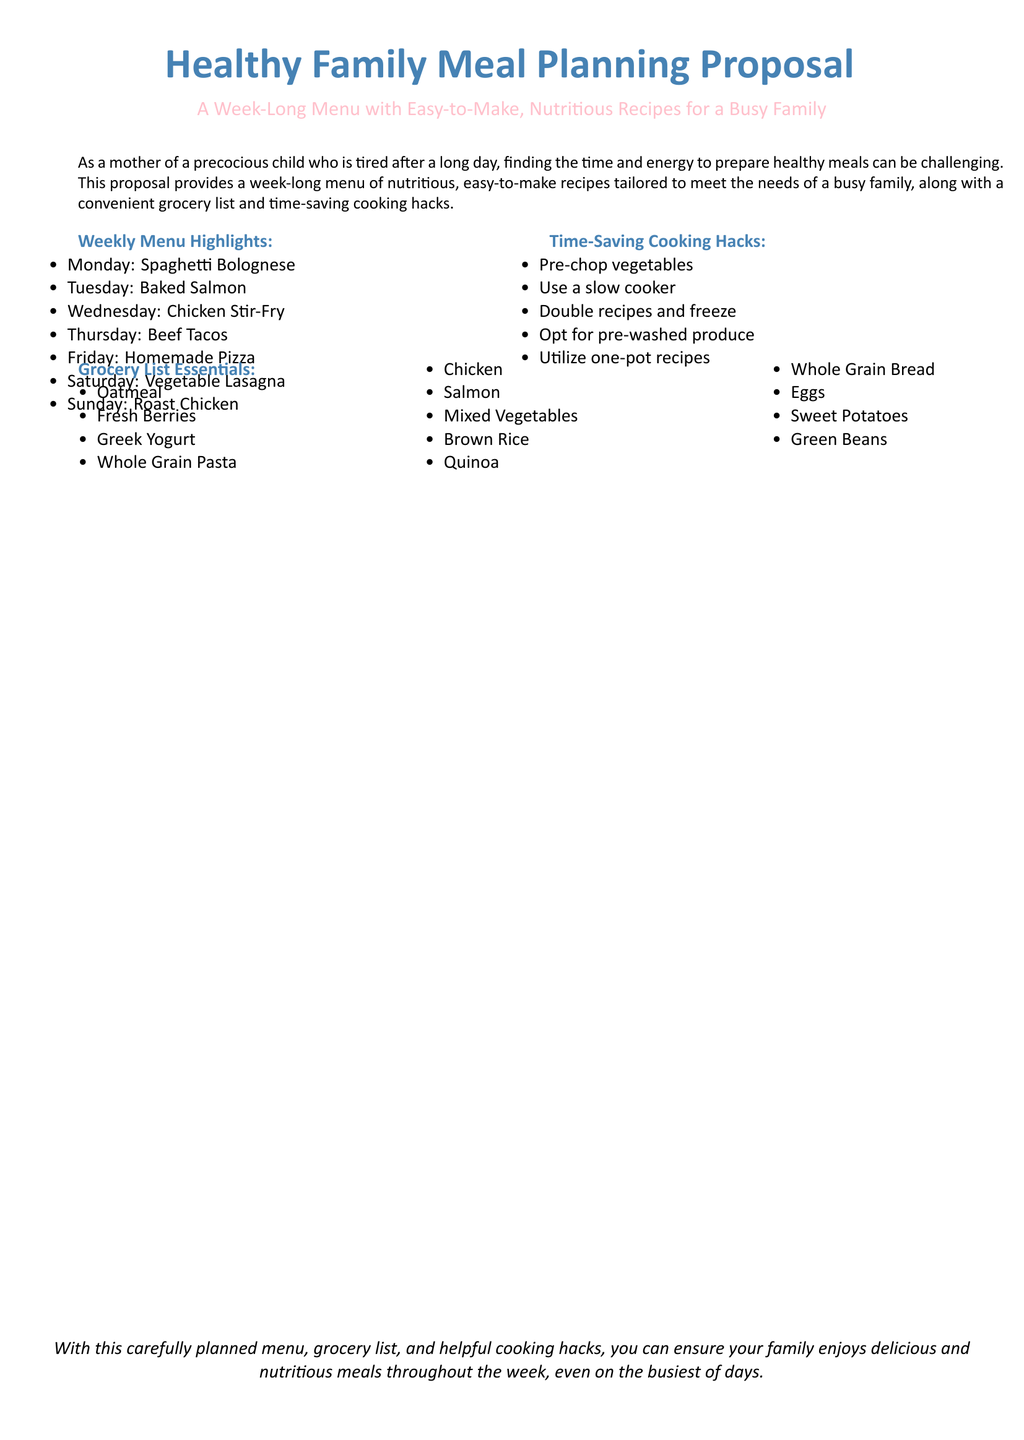What is the title of the proposal? The title is prominently displayed at the top of the document.
Answer: Healthy Family Meal Planning Proposal How many meals are included in the weekly menu? A count of the meals listed under the "Weekly Menu Highlights" section gives the total.
Answer: Seven What recipe is suggested for Tuesday? The menu specifies the meal plan for each day, including Tuesday.
Answer: Baked Salmon What is one time-saving cooking hack mentioned? The document lists multiple cooking hacks under the "Time-Saving Cooking Hacks" section.
Answer: Pre-chop vegetables Which ingredient is included in the grocery list? The grocery list contains various essentials as indicated in the document.
Answer: Greek Yogurt What day of the week features homemade pizza? The weekly menu clearly associates each meal with a specific day.
Answer: Friday How many cooking hacks are provided in total? The total can be counted from the "Time-Saving Cooking Hacks" section.
Answer: Five What type of document is this? The purpose and content of the document indicate its nature.
Answer: Proposal 